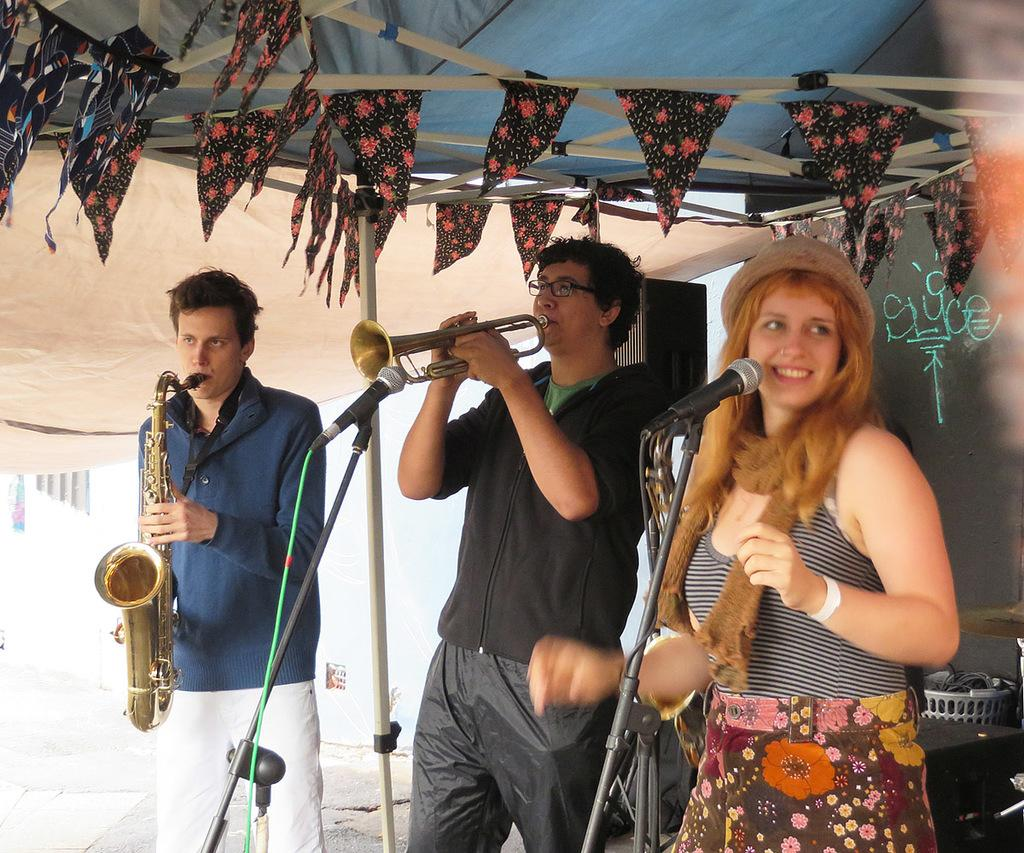What are the people in the image doing? The people in the image are playing musical instruments. What equipment is present to amplify their sound? There are microphones with stands in the image. What structure is visible in the image? There is a roof visible in the image. What decorations are on the roof? There are flags on the roof. What type of quill is being used by the person playing the guitar in the image? There is no quill present in the image; the people are playing musical instruments with modern equipment. Can you see the coat of the person playing the drums in the image? The image does not show any coats or clothing details of the people playing musical instruments. 